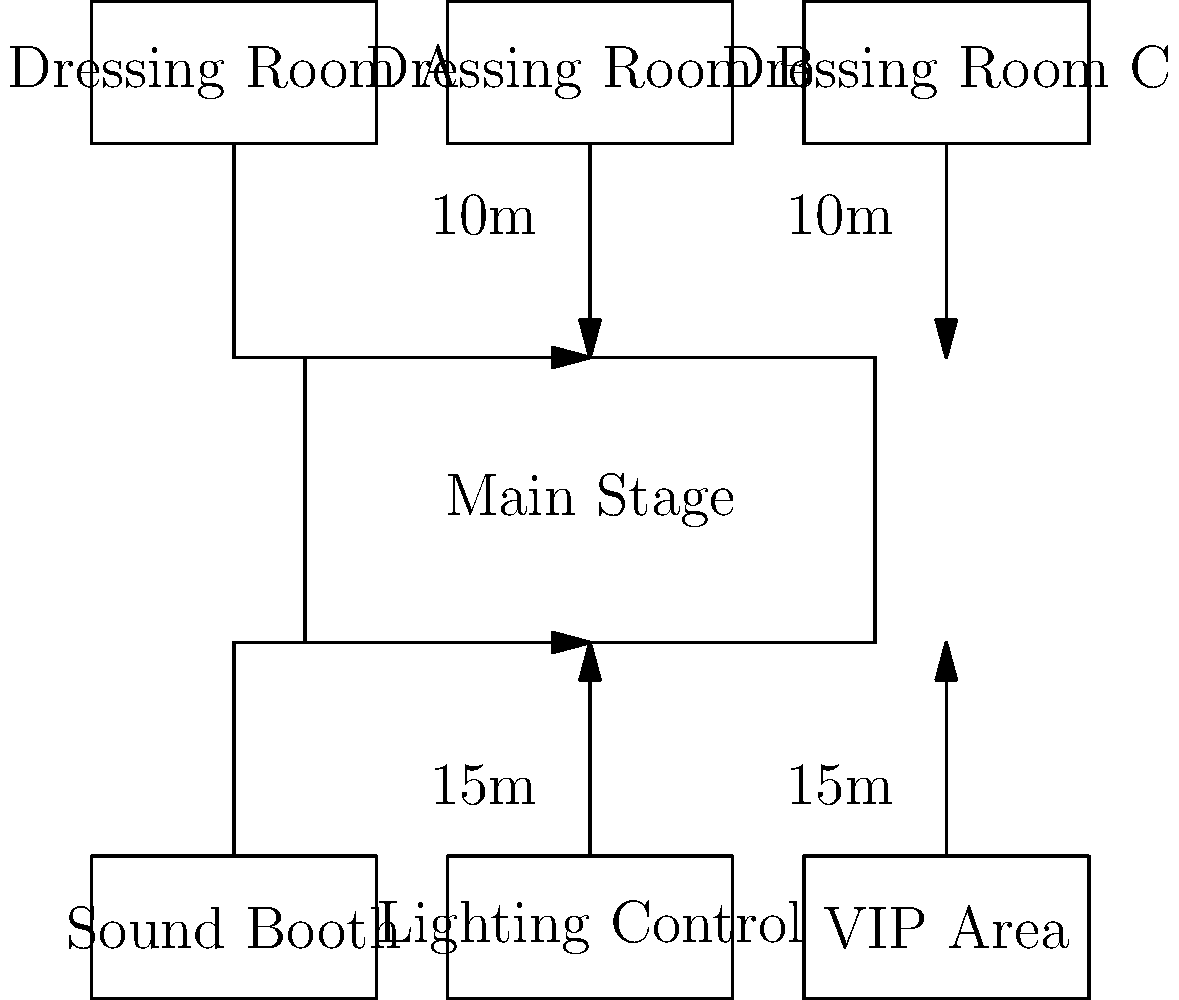Based on the concert rider diagram, what is the total distance an artist would need to walk from Dressing Room A to the VIP Area, passing through the Main Stage? To calculate the total distance, we need to follow these steps:

1. Distance from Dressing Room A to Main Stage:
   - Vertical distance = 10m (given in the diagram)
   - Horizontal distance = 50m (half the width of the Main Stage)
   - Total = $\sqrt{10^2 + 50^2} = \sqrt{100 + 2500} = \sqrt{2600} \approx 50.99m$

2. Distance across the Main Stage:
   - Width of the Main Stage = 80m

3. Distance from Main Stage to VIP Area:
   - Vertical distance = 15m (given in the diagram)
   - Horizontal distance = 50m (half the width of the Main Stage)
   - Total = $\sqrt{15^2 + 50^2} = \sqrt{225 + 2500} = \sqrt{2725} \approx 52.20m$

4. Sum up all distances:
   50.99m + 80m + 52.20m = 183.19m

Therefore, the total distance is approximately 183.19 meters.
Answer: 183.19 meters 